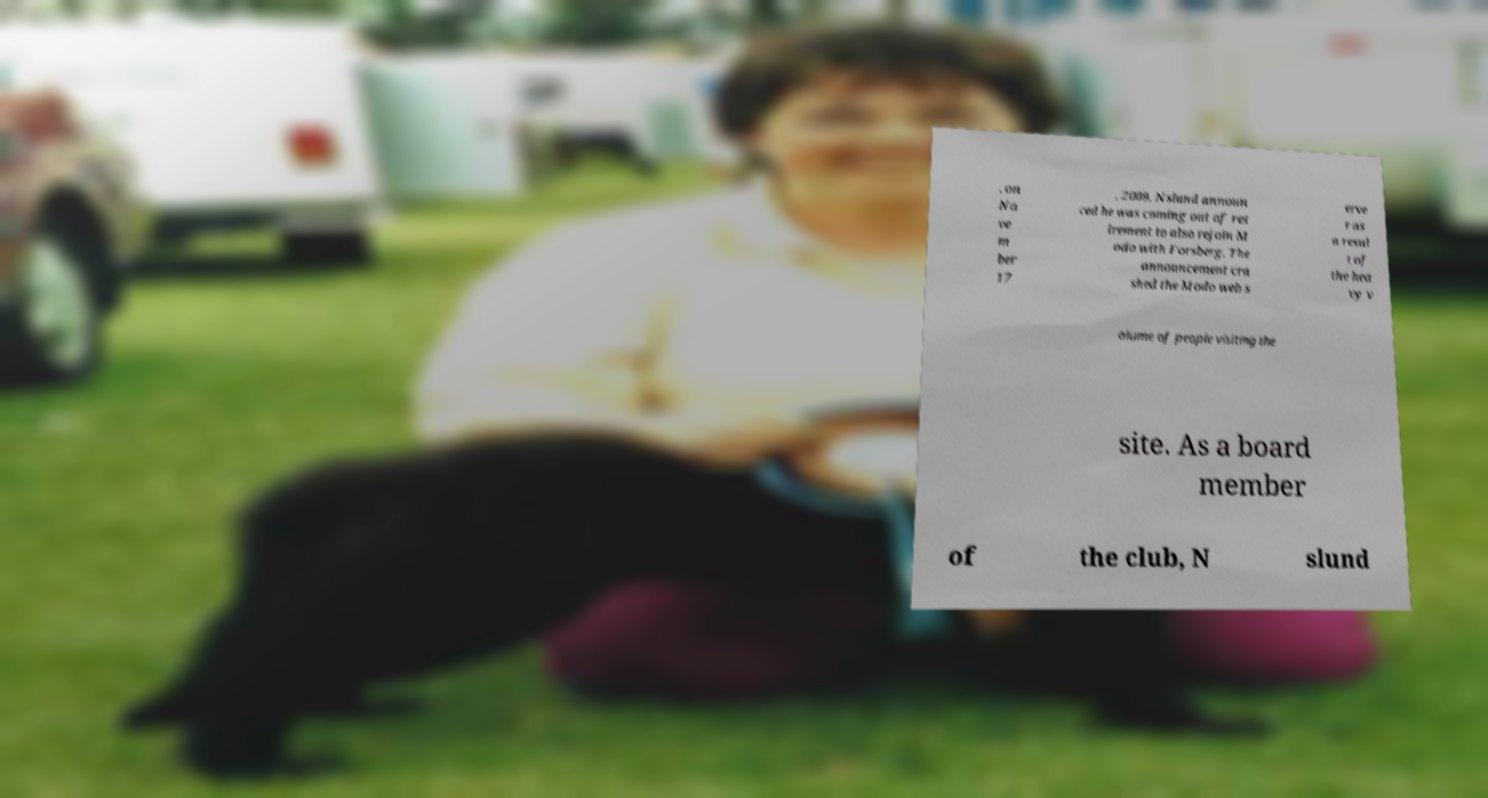Could you extract and type out the text from this image? , on No ve m ber 17 , 2009, Nslund announ ced he was coming out of ret irement to also rejoin M odo with Forsberg. The announcement cra shed the Modo web s erve r as a resul t of the hea vy v olume of people visiting the site. As a board member of the club, N slund 